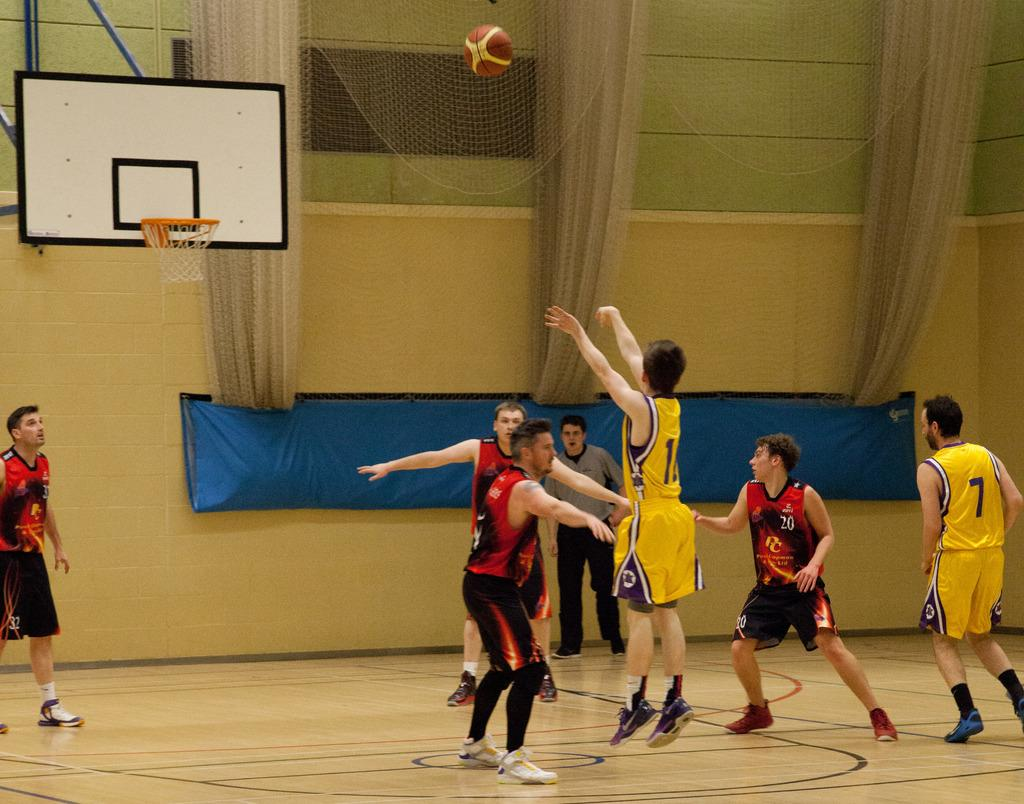<image>
Write a terse but informative summary of the picture. A basketball player wears a jersey that reads 7. 